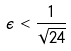<formula> <loc_0><loc_0><loc_500><loc_500>\epsilon < \frac { 1 } { \sqrt { 2 4 } }</formula> 